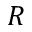Convert formula to latex. <formula><loc_0><loc_0><loc_500><loc_500>R</formula> 